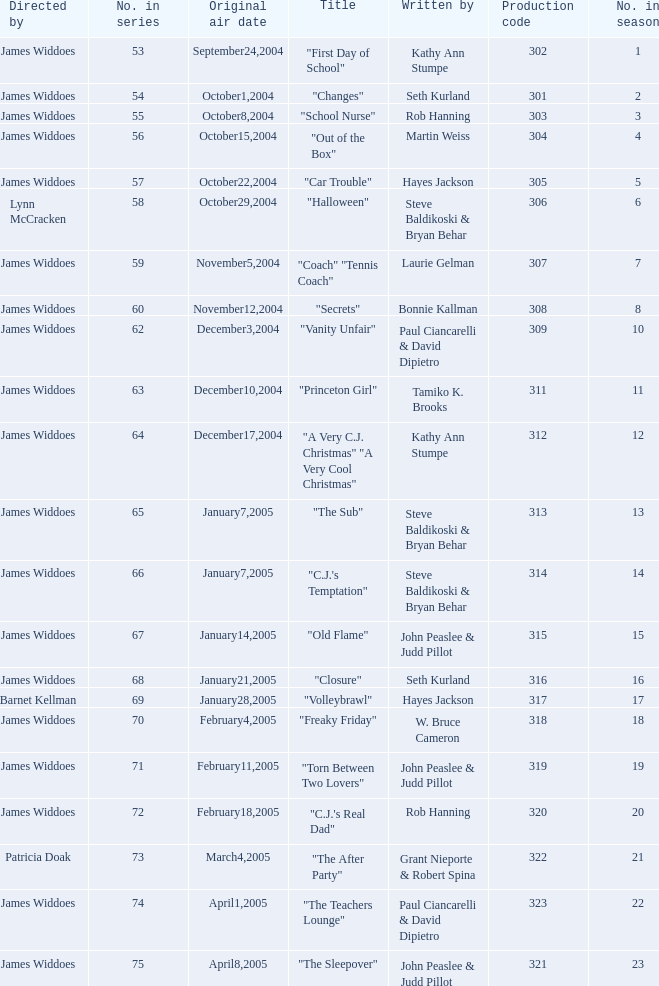What is the production code for episode 3 of the season? 303.0. 